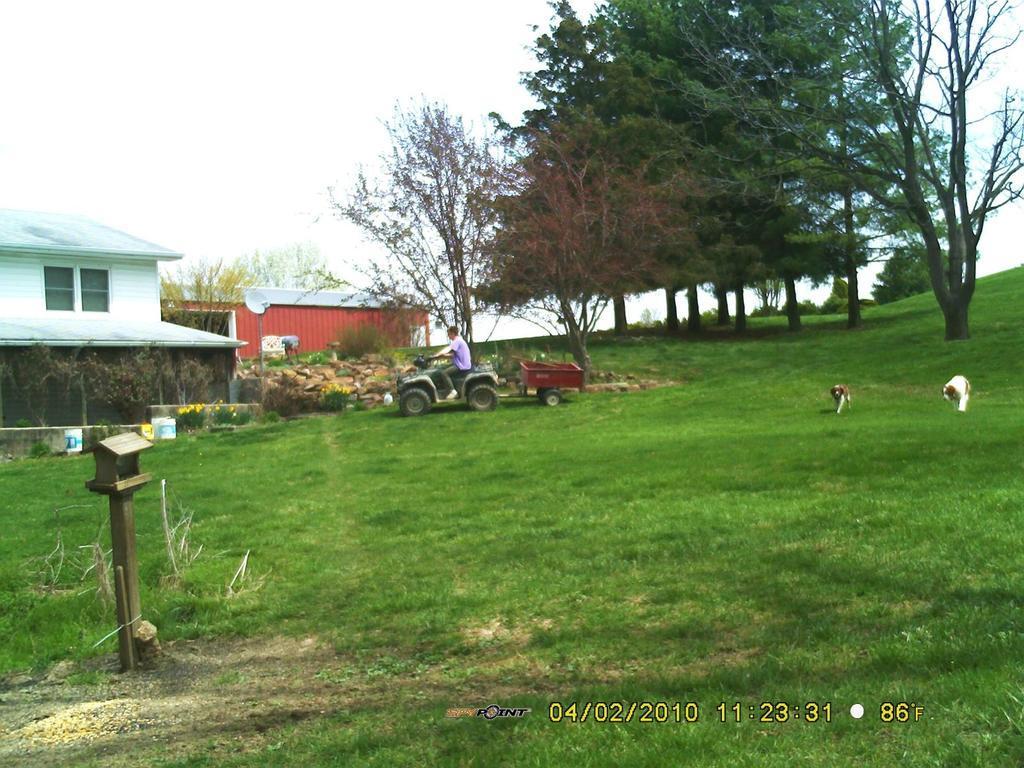Can you describe this image briefly? In this picture we can see a man is seated on the vehicle, beside to him we can find dogs on the grass, in the background we can see few trees and houses. 